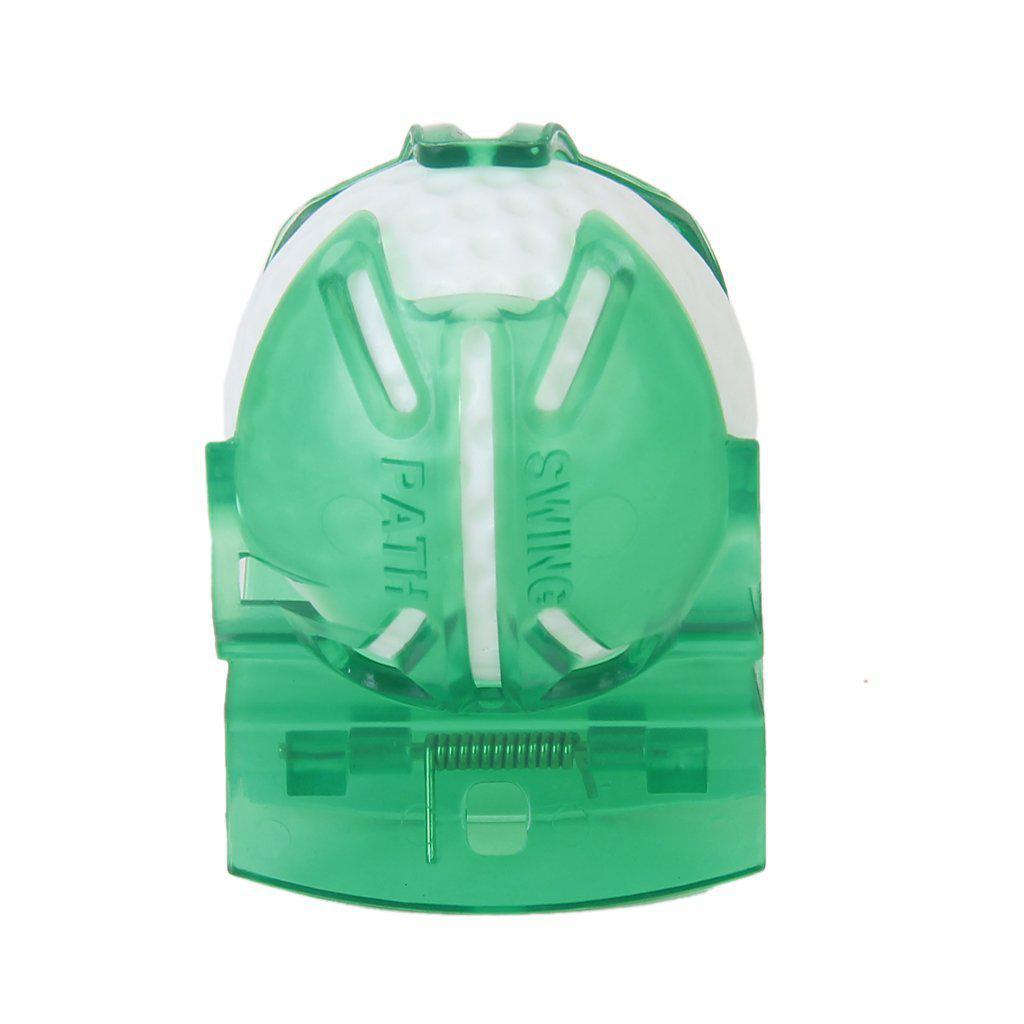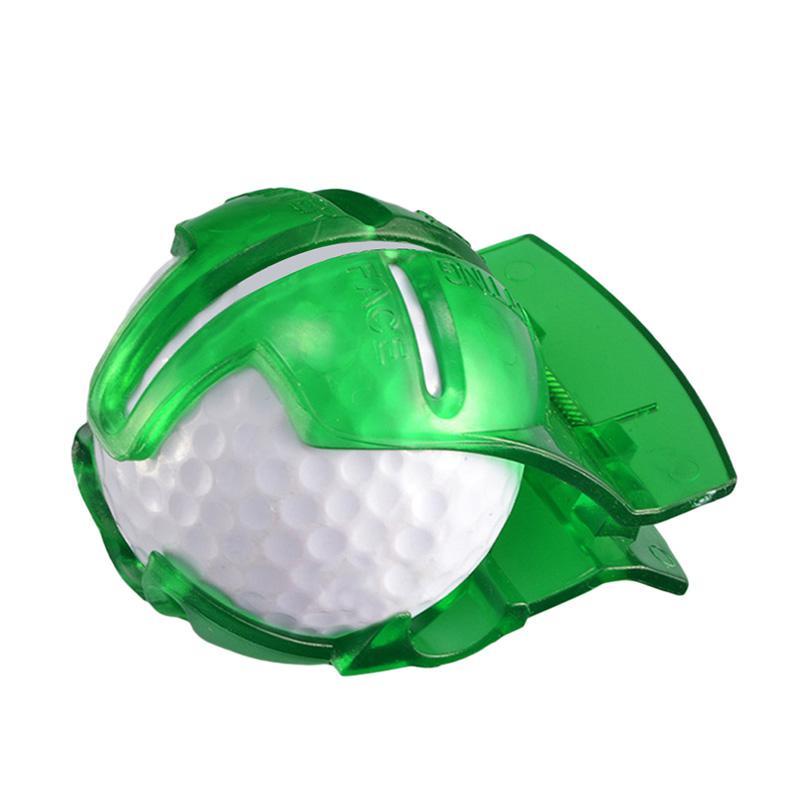The first image is the image on the left, the second image is the image on the right. Given the left and right images, does the statement "In one of the images there is a golf ball with red lines on it." hold true? Answer yes or no. No. The first image is the image on the left, the second image is the image on the right. Analyze the images presented: Is the assertion "There are only two golf balls, and both of them are in translucent green containers." valid? Answer yes or no. Yes. 